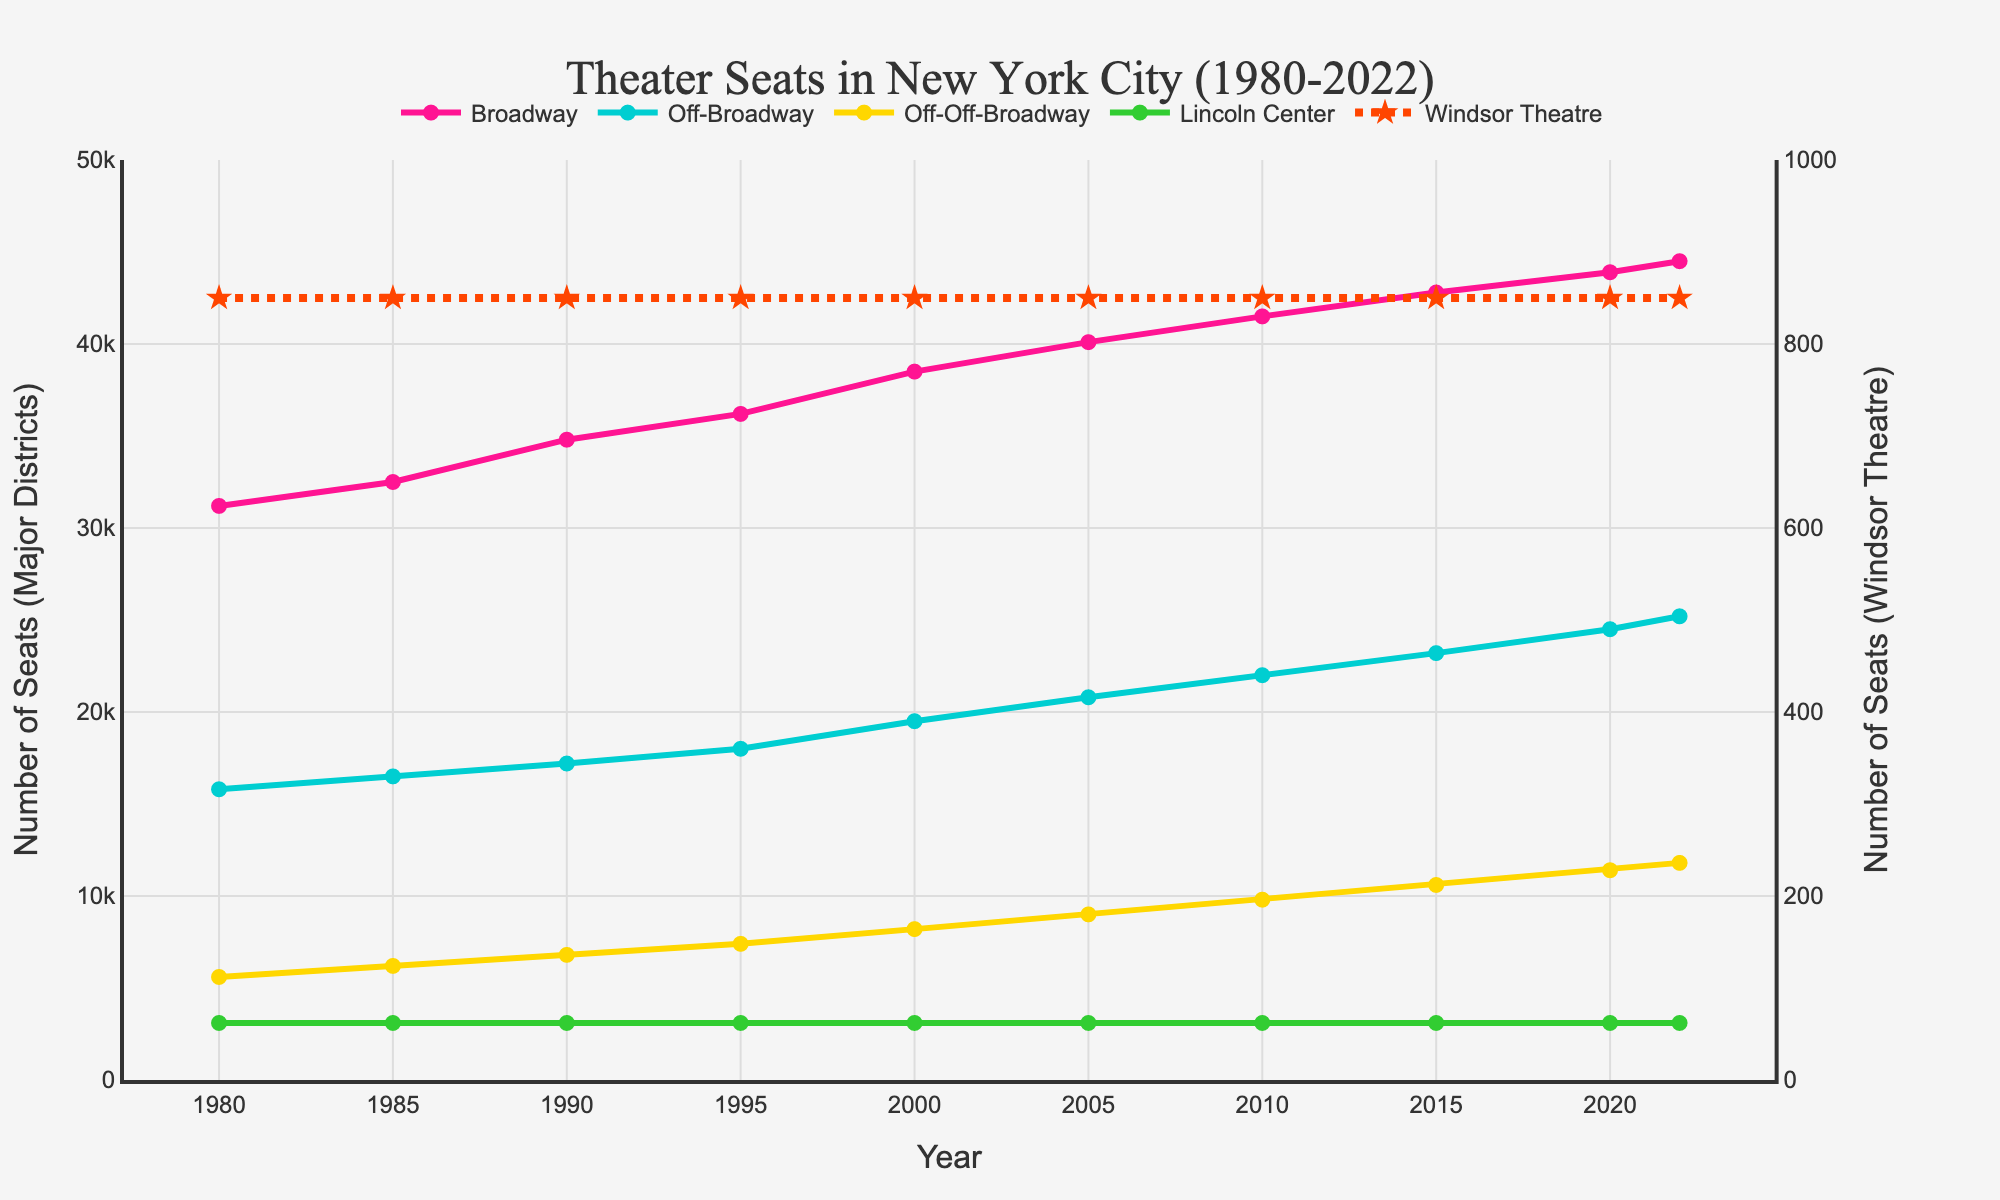What year had the fewest seats available in Broadway? To determine the year with the fewest seats available in Broadway, examine the plot and find the year corresponding to the lowest value on the Broadway line. The line for Broadway has the lowest point at 1980 with 31,200 seats.
Answer: 1980 How many total seats were available in Lincoln Center from 2000 to 2022? To calculate the total seats in Lincoln Center from 2000 to 2022, sum the seats for each year within this range. The values are 3100 for 2000-2022. Therefore, the calculation is 3100 * 10 = 31000.
Answer: 31000 Which theater district experienced the highest increase in seats from 1980 to 2022? To determine which theater district experienced the highest increase, subtract the 1980 seat count from the 2022 seat count for each district and compare. Broadway increased from 31,200 to 44,500 (13,300), Off-Broadway from 15,800 to 25,200 (9,400), Off-Off-Broadway from 5,600 to 11,800 (6,200), Lincoln Center remained constant at 3,100, and Windsor Theatre remained constant at 850. Broadway has the highest increase.
Answer: Broadway Which theater district had the smallest change in seat numbers from 1980 to 2022? Examine the beginning and end points for each district. Windsor Theatre and Lincoln Center both remained constant from 1980 to 2022. Since both had no change, either answer is acceptable.
Answer: Windsor Theatre or Lincoln Center What is the difference in the number of seats between Off-Broadway and Off-Off-Broadway in 2015? Identify the seat values for Off-Broadway and Off-Off-Broadway in 2015 from the plot. For 2015, Off-Broadway had 23,200 seats, and Off-Off-Broadway had 10,600 seats. The difference is 23,200 - 10,600 = 12,600.
Answer: 12,600 What year did Broadway first surpass 40,000 seats? To find when Broadway first surpassed 40,000 seats, look for the first year the Broadway line crosses the 40,000 mark. In 2005, Broadway had 40,100 seats, which is the first instance above 40,000.
Answer: 2005 Compare the trend of seats available in Off-Off-Broadway and Windsor Theatre from 1980 to 2022. Off-Off-Broadway shows a consistent increase from 5,600 in 1980 to 11,800 in 2022. Windsor Theatre remains constant at 850 throughout all years. Therefore, Off-Off-Broadway has an increasing trend while Windsor Theatre has no change.
Answer: Off-Off-Broadway increasing, Windsor Theatre constant 